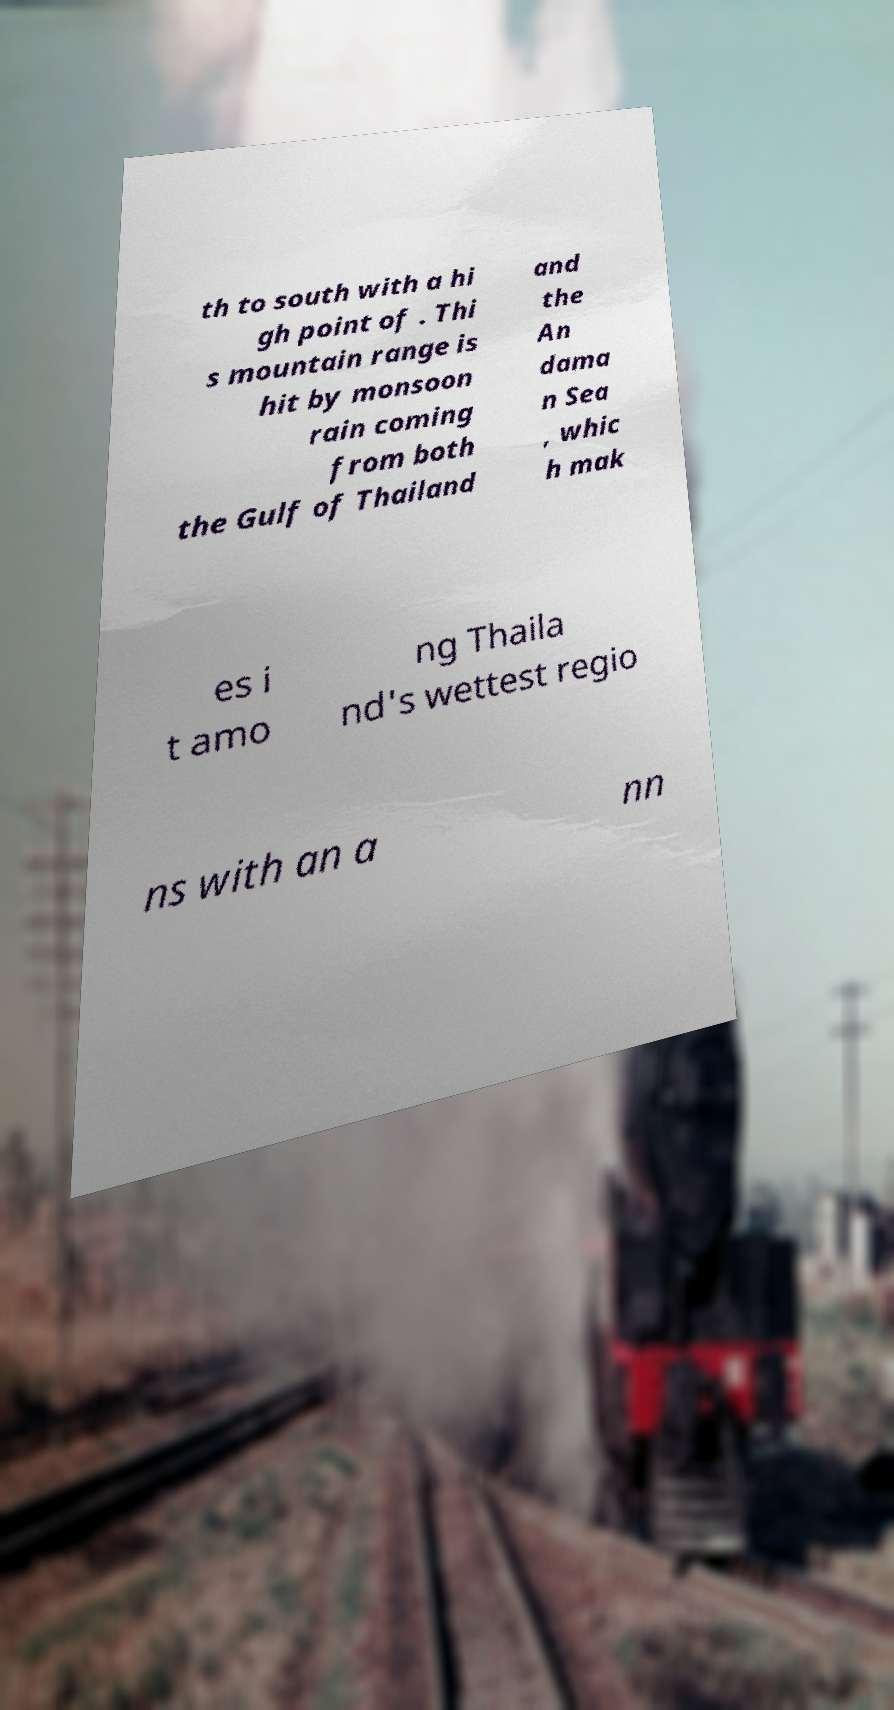Please identify and transcribe the text found in this image. th to south with a hi gh point of . Thi s mountain range is hit by monsoon rain coming from both the Gulf of Thailand and the An dama n Sea , whic h mak es i t amo ng Thaila nd's wettest regio ns with an a nn 